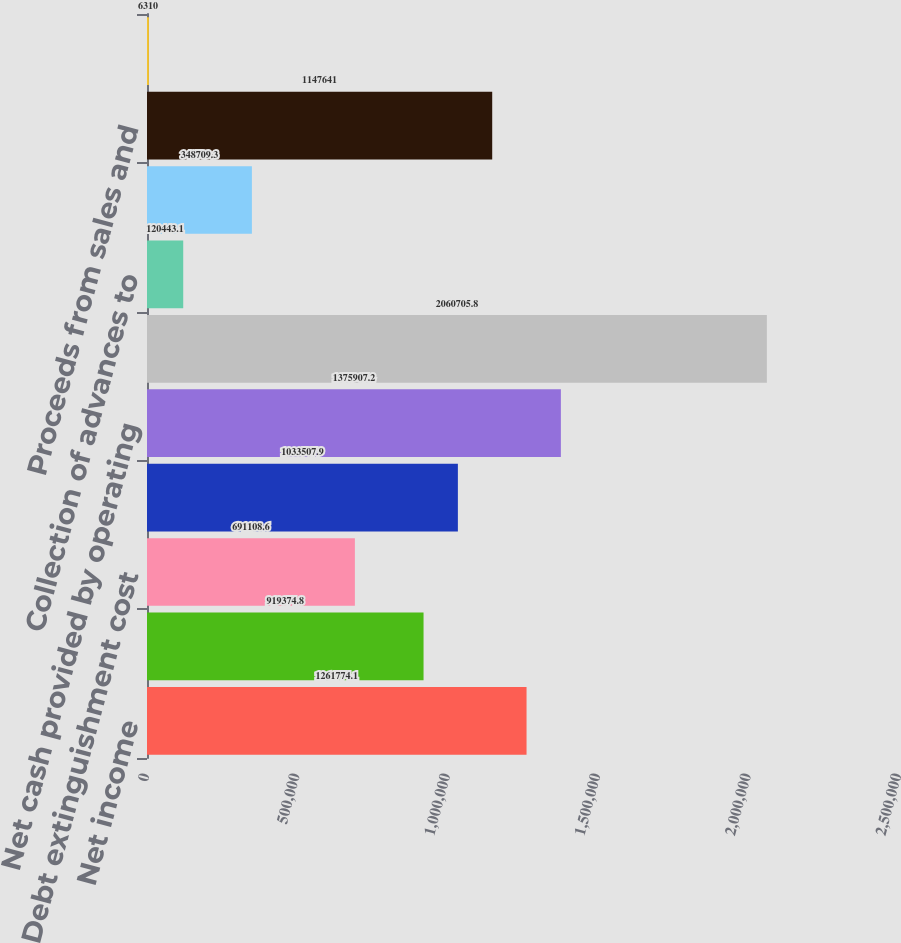<chart> <loc_0><loc_0><loc_500><loc_500><bar_chart><fcel>Net income<fcel>Undistributed net income of<fcel>Debt extinguishment cost<fcel>Other net<fcel>Net cash provided by operating<fcel>Net decrease (increase) in<fcel>Collection of advances to<fcel>Advances to subsidiaries<fcel>Proceeds from sales and<fcel>Decrease of investment in<nl><fcel>1.26177e+06<fcel>919375<fcel>691109<fcel>1.03351e+06<fcel>1.37591e+06<fcel>2.06071e+06<fcel>120443<fcel>348709<fcel>1.14764e+06<fcel>6310<nl></chart> 